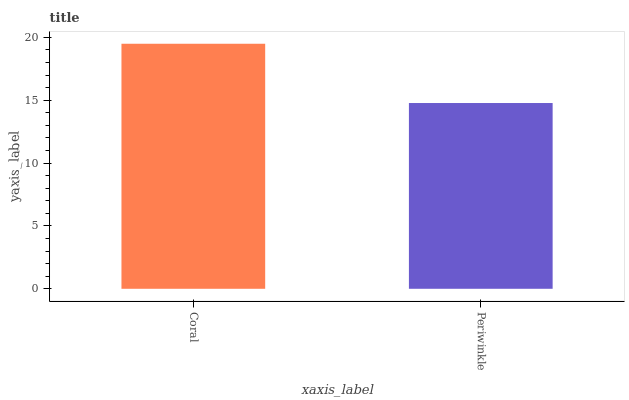Is Periwinkle the minimum?
Answer yes or no. Yes. Is Coral the maximum?
Answer yes or no. Yes. Is Periwinkle the maximum?
Answer yes or no. No. Is Coral greater than Periwinkle?
Answer yes or no. Yes. Is Periwinkle less than Coral?
Answer yes or no. Yes. Is Periwinkle greater than Coral?
Answer yes or no. No. Is Coral less than Periwinkle?
Answer yes or no. No. Is Coral the high median?
Answer yes or no. Yes. Is Periwinkle the low median?
Answer yes or no. Yes. Is Periwinkle the high median?
Answer yes or no. No. Is Coral the low median?
Answer yes or no. No. 